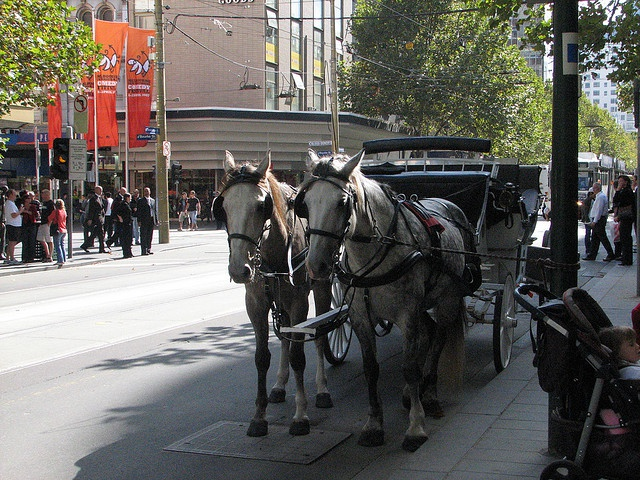Describe the objects in this image and their specific colors. I can see horse in olive, black, gray, darkgray, and white tones, horse in olive, black, gray, darkgray, and white tones, people in olive, black, gray, and maroon tones, bus in olive, gray, lightgray, black, and darkgray tones, and people in olive, black, gray, and darkgray tones in this image. 